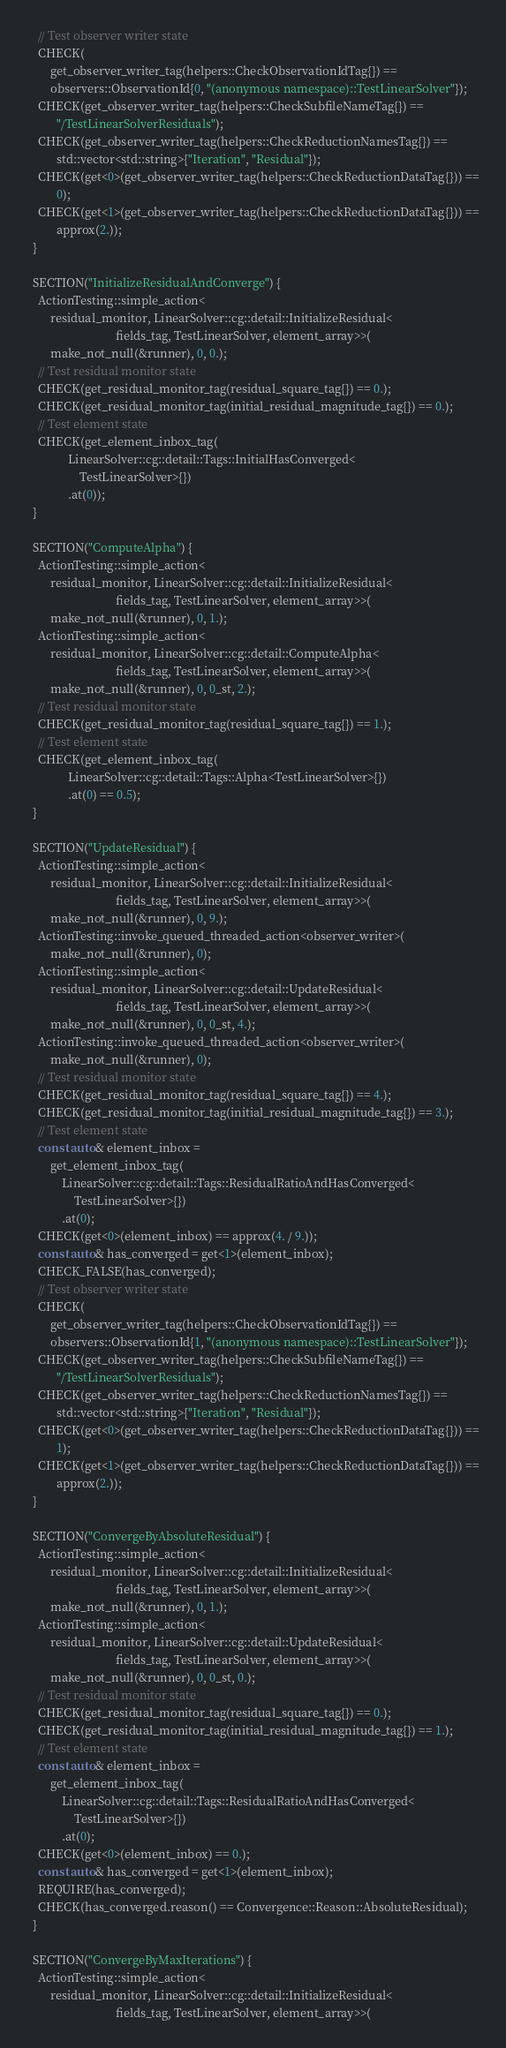<code> <loc_0><loc_0><loc_500><loc_500><_C++_>    // Test observer writer state
    CHECK(
        get_observer_writer_tag(helpers::CheckObservationIdTag{}) ==
        observers::ObservationId{0, "(anonymous namespace)::TestLinearSolver"});
    CHECK(get_observer_writer_tag(helpers::CheckSubfileNameTag{}) ==
          "/TestLinearSolverResiduals");
    CHECK(get_observer_writer_tag(helpers::CheckReductionNamesTag{}) ==
          std::vector<std::string>{"Iteration", "Residual"});
    CHECK(get<0>(get_observer_writer_tag(helpers::CheckReductionDataTag{})) ==
          0);
    CHECK(get<1>(get_observer_writer_tag(helpers::CheckReductionDataTag{})) ==
          approx(2.));
  }

  SECTION("InitializeResidualAndConverge") {
    ActionTesting::simple_action<
        residual_monitor, LinearSolver::cg::detail::InitializeResidual<
                              fields_tag, TestLinearSolver, element_array>>(
        make_not_null(&runner), 0, 0.);
    // Test residual monitor state
    CHECK(get_residual_monitor_tag(residual_square_tag{}) == 0.);
    CHECK(get_residual_monitor_tag(initial_residual_magnitude_tag{}) == 0.);
    // Test element state
    CHECK(get_element_inbox_tag(
              LinearSolver::cg::detail::Tags::InitialHasConverged<
                  TestLinearSolver>{})
              .at(0));
  }

  SECTION("ComputeAlpha") {
    ActionTesting::simple_action<
        residual_monitor, LinearSolver::cg::detail::InitializeResidual<
                              fields_tag, TestLinearSolver, element_array>>(
        make_not_null(&runner), 0, 1.);
    ActionTesting::simple_action<
        residual_monitor, LinearSolver::cg::detail::ComputeAlpha<
                              fields_tag, TestLinearSolver, element_array>>(
        make_not_null(&runner), 0, 0_st, 2.);
    // Test residual monitor state
    CHECK(get_residual_monitor_tag(residual_square_tag{}) == 1.);
    // Test element state
    CHECK(get_element_inbox_tag(
              LinearSolver::cg::detail::Tags::Alpha<TestLinearSolver>{})
              .at(0) == 0.5);
  }

  SECTION("UpdateResidual") {
    ActionTesting::simple_action<
        residual_monitor, LinearSolver::cg::detail::InitializeResidual<
                              fields_tag, TestLinearSolver, element_array>>(
        make_not_null(&runner), 0, 9.);
    ActionTesting::invoke_queued_threaded_action<observer_writer>(
        make_not_null(&runner), 0);
    ActionTesting::simple_action<
        residual_monitor, LinearSolver::cg::detail::UpdateResidual<
                              fields_tag, TestLinearSolver, element_array>>(
        make_not_null(&runner), 0, 0_st, 4.);
    ActionTesting::invoke_queued_threaded_action<observer_writer>(
        make_not_null(&runner), 0);
    // Test residual monitor state
    CHECK(get_residual_monitor_tag(residual_square_tag{}) == 4.);
    CHECK(get_residual_monitor_tag(initial_residual_magnitude_tag{}) == 3.);
    // Test element state
    const auto& element_inbox =
        get_element_inbox_tag(
            LinearSolver::cg::detail::Tags::ResidualRatioAndHasConverged<
                TestLinearSolver>{})
            .at(0);
    CHECK(get<0>(element_inbox) == approx(4. / 9.));
    const auto& has_converged = get<1>(element_inbox);
    CHECK_FALSE(has_converged);
    // Test observer writer state
    CHECK(
        get_observer_writer_tag(helpers::CheckObservationIdTag{}) ==
        observers::ObservationId{1, "(anonymous namespace)::TestLinearSolver"});
    CHECK(get_observer_writer_tag(helpers::CheckSubfileNameTag{}) ==
          "/TestLinearSolverResiduals");
    CHECK(get_observer_writer_tag(helpers::CheckReductionNamesTag{}) ==
          std::vector<std::string>{"Iteration", "Residual"});
    CHECK(get<0>(get_observer_writer_tag(helpers::CheckReductionDataTag{})) ==
          1);
    CHECK(get<1>(get_observer_writer_tag(helpers::CheckReductionDataTag{})) ==
          approx(2.));
  }

  SECTION("ConvergeByAbsoluteResidual") {
    ActionTesting::simple_action<
        residual_monitor, LinearSolver::cg::detail::InitializeResidual<
                              fields_tag, TestLinearSolver, element_array>>(
        make_not_null(&runner), 0, 1.);
    ActionTesting::simple_action<
        residual_monitor, LinearSolver::cg::detail::UpdateResidual<
                              fields_tag, TestLinearSolver, element_array>>(
        make_not_null(&runner), 0, 0_st, 0.);
    // Test residual monitor state
    CHECK(get_residual_monitor_tag(residual_square_tag{}) == 0.);
    CHECK(get_residual_monitor_tag(initial_residual_magnitude_tag{}) == 1.);
    // Test element state
    const auto& element_inbox =
        get_element_inbox_tag(
            LinearSolver::cg::detail::Tags::ResidualRatioAndHasConverged<
                TestLinearSolver>{})
            .at(0);
    CHECK(get<0>(element_inbox) == 0.);
    const auto& has_converged = get<1>(element_inbox);
    REQUIRE(has_converged);
    CHECK(has_converged.reason() == Convergence::Reason::AbsoluteResidual);
  }

  SECTION("ConvergeByMaxIterations") {
    ActionTesting::simple_action<
        residual_monitor, LinearSolver::cg::detail::InitializeResidual<
                              fields_tag, TestLinearSolver, element_array>>(</code> 